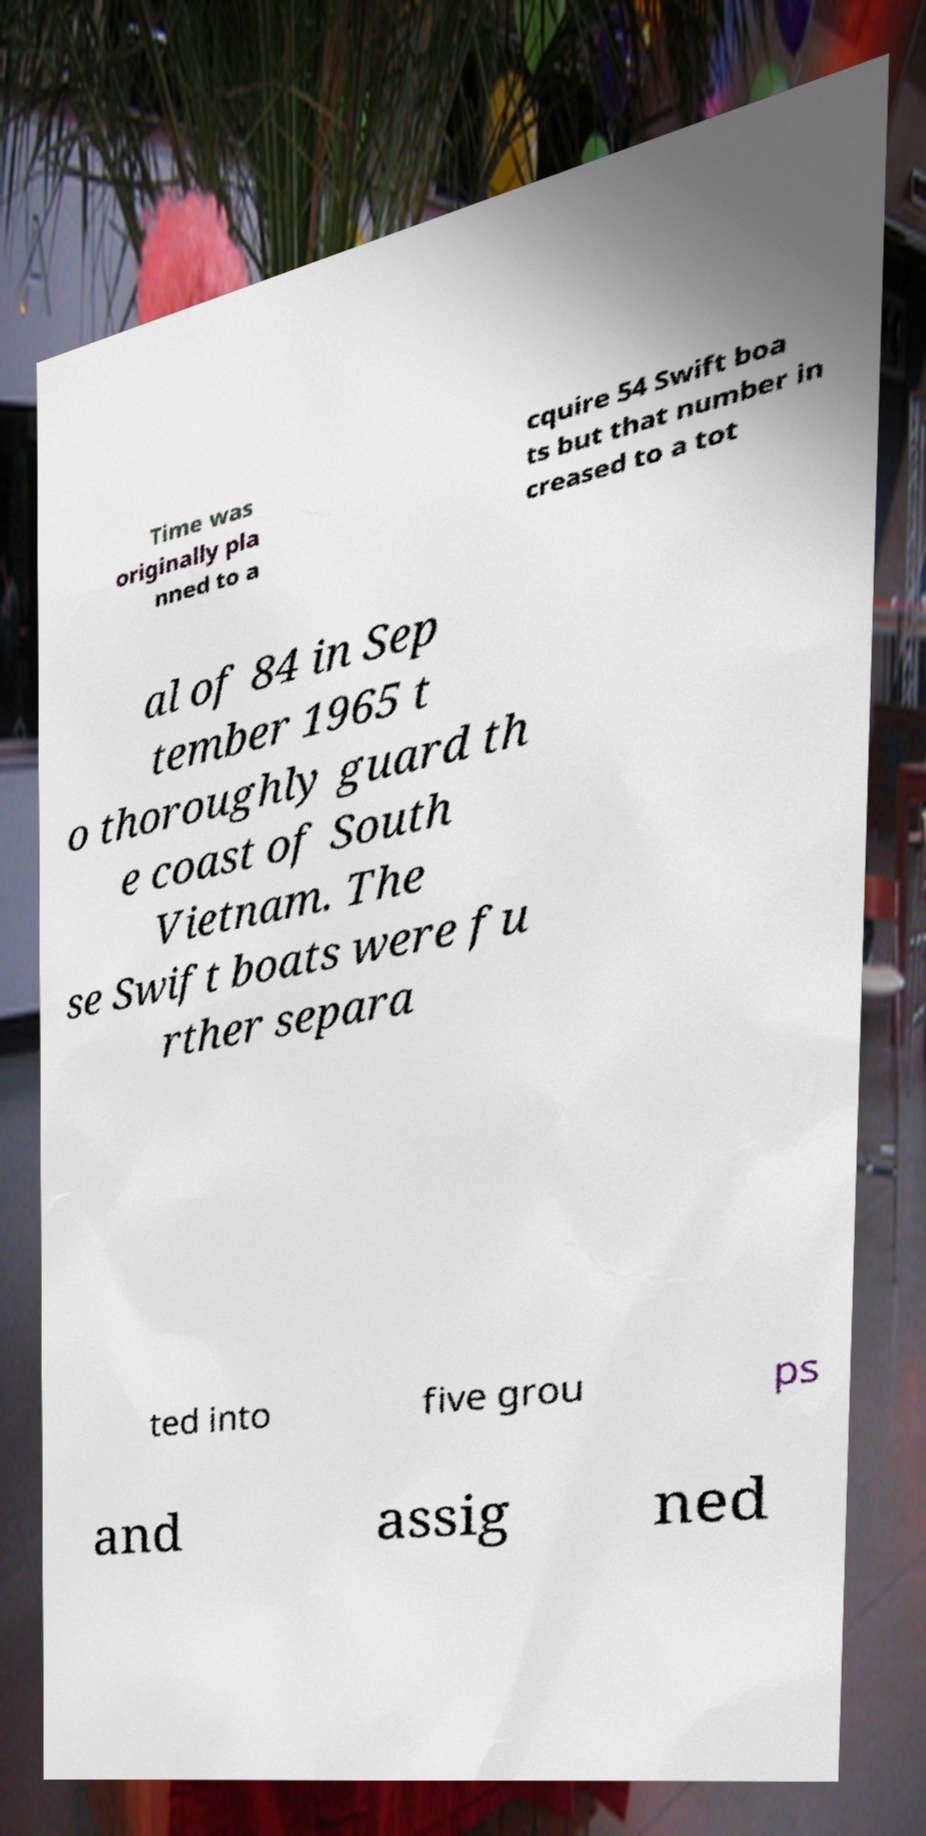Please read and relay the text visible in this image. What does it say? Time was originally pla nned to a cquire 54 Swift boa ts but that number in creased to a tot al of 84 in Sep tember 1965 t o thoroughly guard th e coast of South Vietnam. The se Swift boats were fu rther separa ted into five grou ps and assig ned 